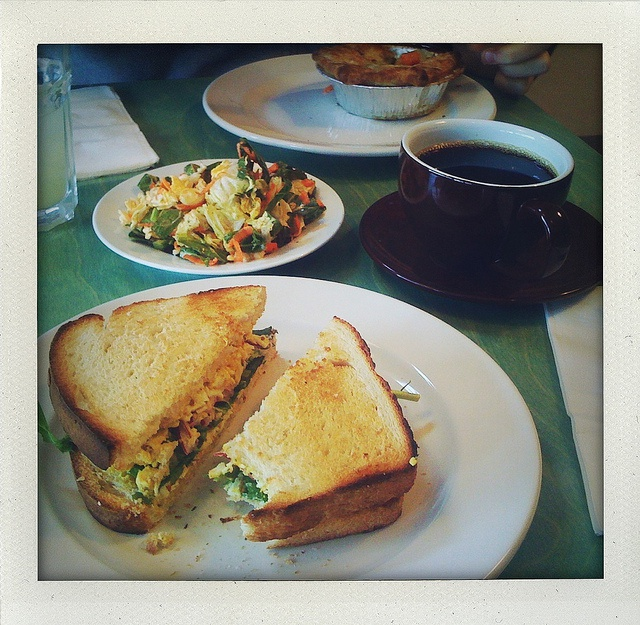Describe the objects in this image and their specific colors. I can see dining table in lightgray, black, darkgray, gray, and tan tones, sandwich in lightgray, tan, olive, and maroon tones, sandwich in lightgray, tan, maroon, and brown tones, cup in lightgray, black, navy, gray, and darkgray tones, and bowl in lightgray, maroon, and gray tones in this image. 